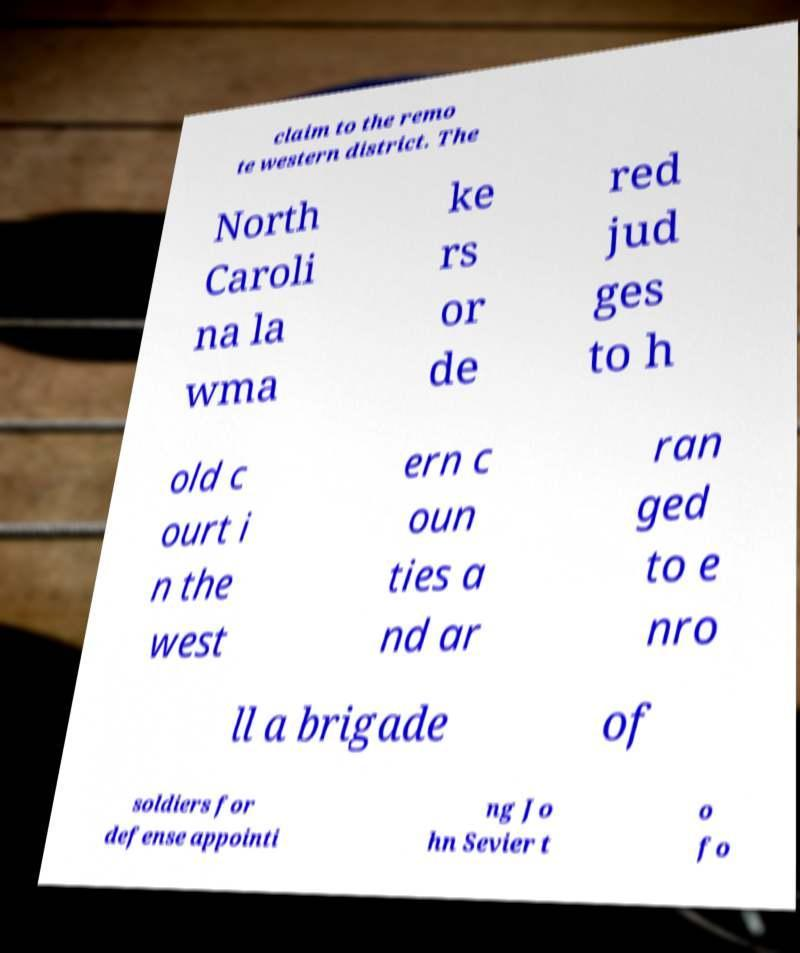What messages or text are displayed in this image? I need them in a readable, typed format. claim to the remo te western district. The North Caroli na la wma ke rs or de red jud ges to h old c ourt i n the west ern c oun ties a nd ar ran ged to e nro ll a brigade of soldiers for defense appointi ng Jo hn Sevier t o fo 